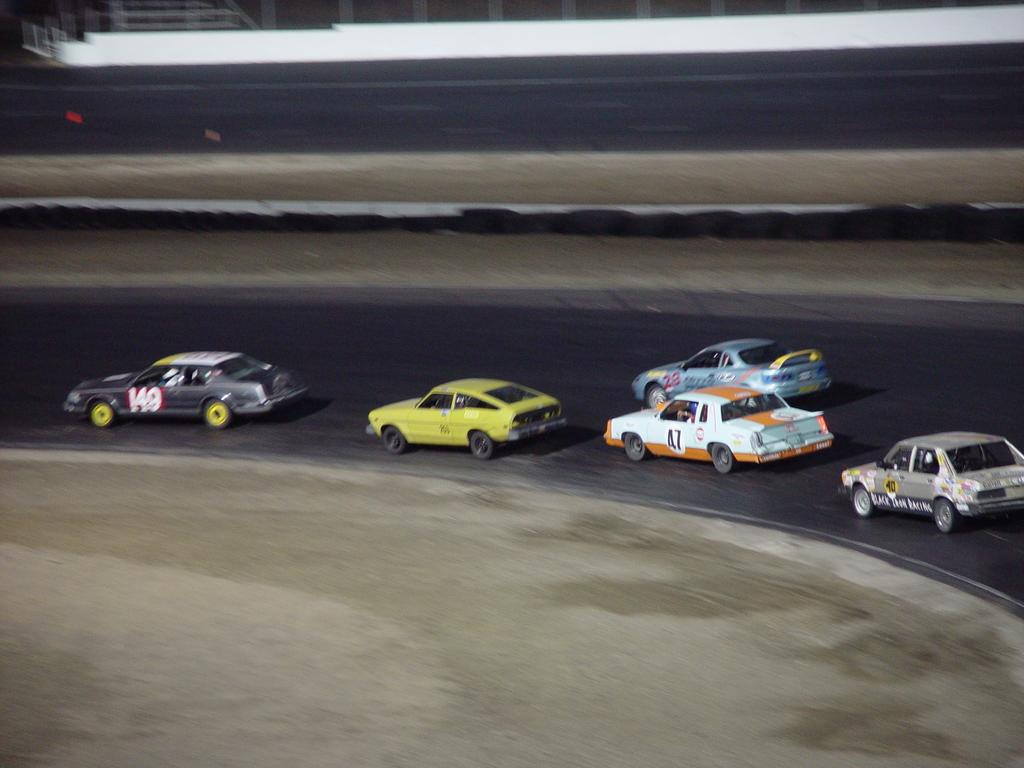What is the main subject in the center of the image? There are cars in the center of the image. What is located at the bottom of the image? There is a road and sand present at the bottom of the image. Can you describe the background of the image? There is a road and buildings visible in the background of the image. What is the temperature in the image, measured in degrees? The temperature cannot be determined from the image, as it does not contain any information about the weather or climate. 